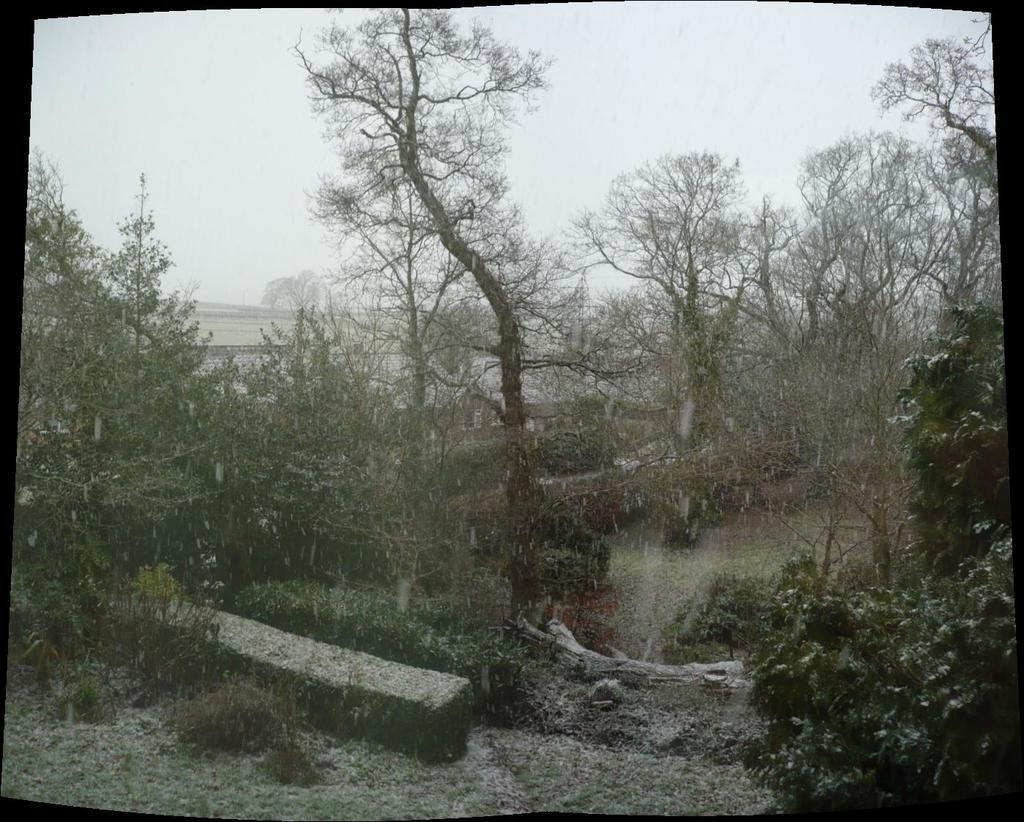What type of vegetation can be seen in the image? There is a group of trees in the image. What else can be seen on the trees in the image? There are water drops visible on the trees in the image. What other objects are present in the image? There is a rock and a wall in the image. What is the condition of the sky in the image? The sky is visible in the image and appears cloudy. What type of drain can be seen in the image? There is no drain present in the image. How does the wrist of the person in the image look? There is no person present in the image, so it is not possible to describe their wrist. 